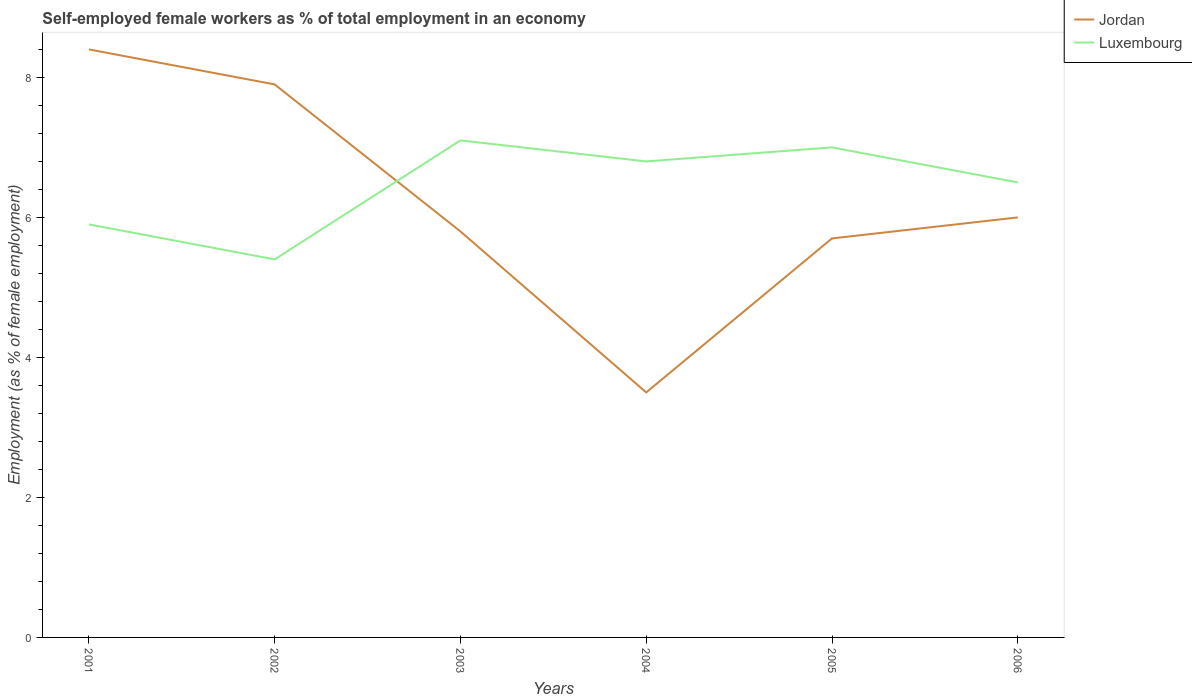How many different coloured lines are there?
Provide a succinct answer. 2. Across all years, what is the maximum percentage of self-employed female workers in Luxembourg?
Your answer should be very brief. 5.4. In which year was the percentage of self-employed female workers in Jordan maximum?
Your answer should be very brief. 2004. What is the total percentage of self-employed female workers in Jordan in the graph?
Offer a terse response. 0.1. What is the difference between the highest and the second highest percentage of self-employed female workers in Luxembourg?
Provide a short and direct response. 1.7. How many lines are there?
Offer a terse response. 2. How many years are there in the graph?
Offer a very short reply. 6. Are the values on the major ticks of Y-axis written in scientific E-notation?
Offer a terse response. No. Does the graph contain any zero values?
Your answer should be very brief. No. How are the legend labels stacked?
Offer a very short reply. Vertical. What is the title of the graph?
Offer a terse response. Self-employed female workers as % of total employment in an economy. What is the label or title of the X-axis?
Give a very brief answer. Years. What is the label or title of the Y-axis?
Make the answer very short. Employment (as % of female employment). What is the Employment (as % of female employment) in Jordan in 2001?
Your response must be concise. 8.4. What is the Employment (as % of female employment) of Luxembourg in 2001?
Make the answer very short. 5.9. What is the Employment (as % of female employment) of Jordan in 2002?
Your answer should be very brief. 7.9. What is the Employment (as % of female employment) in Luxembourg in 2002?
Give a very brief answer. 5.4. What is the Employment (as % of female employment) in Jordan in 2003?
Keep it short and to the point. 5.8. What is the Employment (as % of female employment) in Luxembourg in 2003?
Make the answer very short. 7.1. What is the Employment (as % of female employment) of Jordan in 2004?
Provide a succinct answer. 3.5. What is the Employment (as % of female employment) of Luxembourg in 2004?
Your response must be concise. 6.8. What is the Employment (as % of female employment) of Jordan in 2005?
Keep it short and to the point. 5.7. What is the Employment (as % of female employment) of Luxembourg in 2005?
Your answer should be very brief. 7. What is the Employment (as % of female employment) in Luxembourg in 2006?
Your answer should be very brief. 6.5. Across all years, what is the maximum Employment (as % of female employment) of Jordan?
Offer a terse response. 8.4. Across all years, what is the maximum Employment (as % of female employment) of Luxembourg?
Your response must be concise. 7.1. Across all years, what is the minimum Employment (as % of female employment) of Luxembourg?
Offer a very short reply. 5.4. What is the total Employment (as % of female employment) of Jordan in the graph?
Provide a succinct answer. 37.3. What is the total Employment (as % of female employment) of Luxembourg in the graph?
Offer a terse response. 38.7. What is the difference between the Employment (as % of female employment) in Luxembourg in 2001 and that in 2002?
Your response must be concise. 0.5. What is the difference between the Employment (as % of female employment) in Jordan in 2001 and that in 2003?
Your response must be concise. 2.6. What is the difference between the Employment (as % of female employment) of Luxembourg in 2001 and that in 2003?
Offer a very short reply. -1.2. What is the difference between the Employment (as % of female employment) in Luxembourg in 2001 and that in 2004?
Offer a terse response. -0.9. What is the difference between the Employment (as % of female employment) of Jordan in 2001 and that in 2005?
Offer a terse response. 2.7. What is the difference between the Employment (as % of female employment) in Luxembourg in 2001 and that in 2006?
Provide a short and direct response. -0.6. What is the difference between the Employment (as % of female employment) of Luxembourg in 2002 and that in 2003?
Provide a succinct answer. -1.7. What is the difference between the Employment (as % of female employment) of Jordan in 2002 and that in 2004?
Your answer should be compact. 4.4. What is the difference between the Employment (as % of female employment) of Luxembourg in 2002 and that in 2004?
Keep it short and to the point. -1.4. What is the difference between the Employment (as % of female employment) in Jordan in 2002 and that in 2005?
Offer a terse response. 2.2. What is the difference between the Employment (as % of female employment) in Jordan in 2002 and that in 2006?
Keep it short and to the point. 1.9. What is the difference between the Employment (as % of female employment) in Jordan in 2003 and that in 2004?
Provide a short and direct response. 2.3. What is the difference between the Employment (as % of female employment) of Luxembourg in 2003 and that in 2004?
Provide a short and direct response. 0.3. What is the difference between the Employment (as % of female employment) in Luxembourg in 2003 and that in 2005?
Make the answer very short. 0.1. What is the difference between the Employment (as % of female employment) in Jordan in 2003 and that in 2006?
Your response must be concise. -0.2. What is the difference between the Employment (as % of female employment) of Luxembourg in 2003 and that in 2006?
Offer a very short reply. 0.6. What is the difference between the Employment (as % of female employment) in Jordan in 2004 and that in 2006?
Give a very brief answer. -2.5. What is the difference between the Employment (as % of female employment) of Luxembourg in 2005 and that in 2006?
Your response must be concise. 0.5. What is the difference between the Employment (as % of female employment) of Jordan in 2001 and the Employment (as % of female employment) of Luxembourg in 2003?
Offer a terse response. 1.3. What is the difference between the Employment (as % of female employment) of Jordan in 2001 and the Employment (as % of female employment) of Luxembourg in 2004?
Your response must be concise. 1.6. What is the difference between the Employment (as % of female employment) in Jordan in 2001 and the Employment (as % of female employment) in Luxembourg in 2005?
Ensure brevity in your answer.  1.4. What is the difference between the Employment (as % of female employment) of Jordan in 2001 and the Employment (as % of female employment) of Luxembourg in 2006?
Provide a short and direct response. 1.9. What is the difference between the Employment (as % of female employment) in Jordan in 2002 and the Employment (as % of female employment) in Luxembourg in 2003?
Offer a terse response. 0.8. What is the difference between the Employment (as % of female employment) of Jordan in 2002 and the Employment (as % of female employment) of Luxembourg in 2005?
Offer a very short reply. 0.9. What is the difference between the Employment (as % of female employment) in Jordan in 2003 and the Employment (as % of female employment) in Luxembourg in 2005?
Provide a succinct answer. -1.2. What is the difference between the Employment (as % of female employment) in Jordan in 2003 and the Employment (as % of female employment) in Luxembourg in 2006?
Keep it short and to the point. -0.7. What is the difference between the Employment (as % of female employment) in Jordan in 2004 and the Employment (as % of female employment) in Luxembourg in 2006?
Ensure brevity in your answer.  -3. What is the difference between the Employment (as % of female employment) of Jordan in 2005 and the Employment (as % of female employment) of Luxembourg in 2006?
Your answer should be very brief. -0.8. What is the average Employment (as % of female employment) in Jordan per year?
Your answer should be compact. 6.22. What is the average Employment (as % of female employment) of Luxembourg per year?
Ensure brevity in your answer.  6.45. In the year 2001, what is the difference between the Employment (as % of female employment) of Jordan and Employment (as % of female employment) of Luxembourg?
Your answer should be very brief. 2.5. In the year 2002, what is the difference between the Employment (as % of female employment) in Jordan and Employment (as % of female employment) in Luxembourg?
Provide a succinct answer. 2.5. In the year 2005, what is the difference between the Employment (as % of female employment) of Jordan and Employment (as % of female employment) of Luxembourg?
Your answer should be very brief. -1.3. In the year 2006, what is the difference between the Employment (as % of female employment) of Jordan and Employment (as % of female employment) of Luxembourg?
Offer a very short reply. -0.5. What is the ratio of the Employment (as % of female employment) in Jordan in 2001 to that in 2002?
Make the answer very short. 1.06. What is the ratio of the Employment (as % of female employment) in Luxembourg in 2001 to that in 2002?
Ensure brevity in your answer.  1.09. What is the ratio of the Employment (as % of female employment) in Jordan in 2001 to that in 2003?
Offer a terse response. 1.45. What is the ratio of the Employment (as % of female employment) in Luxembourg in 2001 to that in 2003?
Offer a terse response. 0.83. What is the ratio of the Employment (as % of female employment) in Jordan in 2001 to that in 2004?
Keep it short and to the point. 2.4. What is the ratio of the Employment (as % of female employment) of Luxembourg in 2001 to that in 2004?
Offer a terse response. 0.87. What is the ratio of the Employment (as % of female employment) in Jordan in 2001 to that in 2005?
Ensure brevity in your answer.  1.47. What is the ratio of the Employment (as % of female employment) in Luxembourg in 2001 to that in 2005?
Ensure brevity in your answer.  0.84. What is the ratio of the Employment (as % of female employment) of Jordan in 2001 to that in 2006?
Your answer should be very brief. 1.4. What is the ratio of the Employment (as % of female employment) in Luxembourg in 2001 to that in 2006?
Provide a short and direct response. 0.91. What is the ratio of the Employment (as % of female employment) of Jordan in 2002 to that in 2003?
Give a very brief answer. 1.36. What is the ratio of the Employment (as % of female employment) in Luxembourg in 2002 to that in 2003?
Give a very brief answer. 0.76. What is the ratio of the Employment (as % of female employment) in Jordan in 2002 to that in 2004?
Provide a short and direct response. 2.26. What is the ratio of the Employment (as % of female employment) of Luxembourg in 2002 to that in 2004?
Provide a succinct answer. 0.79. What is the ratio of the Employment (as % of female employment) in Jordan in 2002 to that in 2005?
Offer a very short reply. 1.39. What is the ratio of the Employment (as % of female employment) in Luxembourg in 2002 to that in 2005?
Your response must be concise. 0.77. What is the ratio of the Employment (as % of female employment) of Jordan in 2002 to that in 2006?
Your response must be concise. 1.32. What is the ratio of the Employment (as % of female employment) of Luxembourg in 2002 to that in 2006?
Provide a succinct answer. 0.83. What is the ratio of the Employment (as % of female employment) of Jordan in 2003 to that in 2004?
Provide a short and direct response. 1.66. What is the ratio of the Employment (as % of female employment) of Luxembourg in 2003 to that in 2004?
Provide a succinct answer. 1.04. What is the ratio of the Employment (as % of female employment) in Jordan in 2003 to that in 2005?
Provide a short and direct response. 1.02. What is the ratio of the Employment (as % of female employment) of Luxembourg in 2003 to that in 2005?
Provide a succinct answer. 1.01. What is the ratio of the Employment (as % of female employment) in Jordan in 2003 to that in 2006?
Your answer should be very brief. 0.97. What is the ratio of the Employment (as % of female employment) of Luxembourg in 2003 to that in 2006?
Keep it short and to the point. 1.09. What is the ratio of the Employment (as % of female employment) in Jordan in 2004 to that in 2005?
Provide a succinct answer. 0.61. What is the ratio of the Employment (as % of female employment) of Luxembourg in 2004 to that in 2005?
Your response must be concise. 0.97. What is the ratio of the Employment (as % of female employment) in Jordan in 2004 to that in 2006?
Your answer should be very brief. 0.58. What is the ratio of the Employment (as % of female employment) in Luxembourg in 2004 to that in 2006?
Make the answer very short. 1.05. What is the ratio of the Employment (as % of female employment) in Jordan in 2005 to that in 2006?
Make the answer very short. 0.95. What is the difference between the highest and the second highest Employment (as % of female employment) in Jordan?
Your answer should be very brief. 0.5. What is the difference between the highest and the lowest Employment (as % of female employment) of Luxembourg?
Keep it short and to the point. 1.7. 